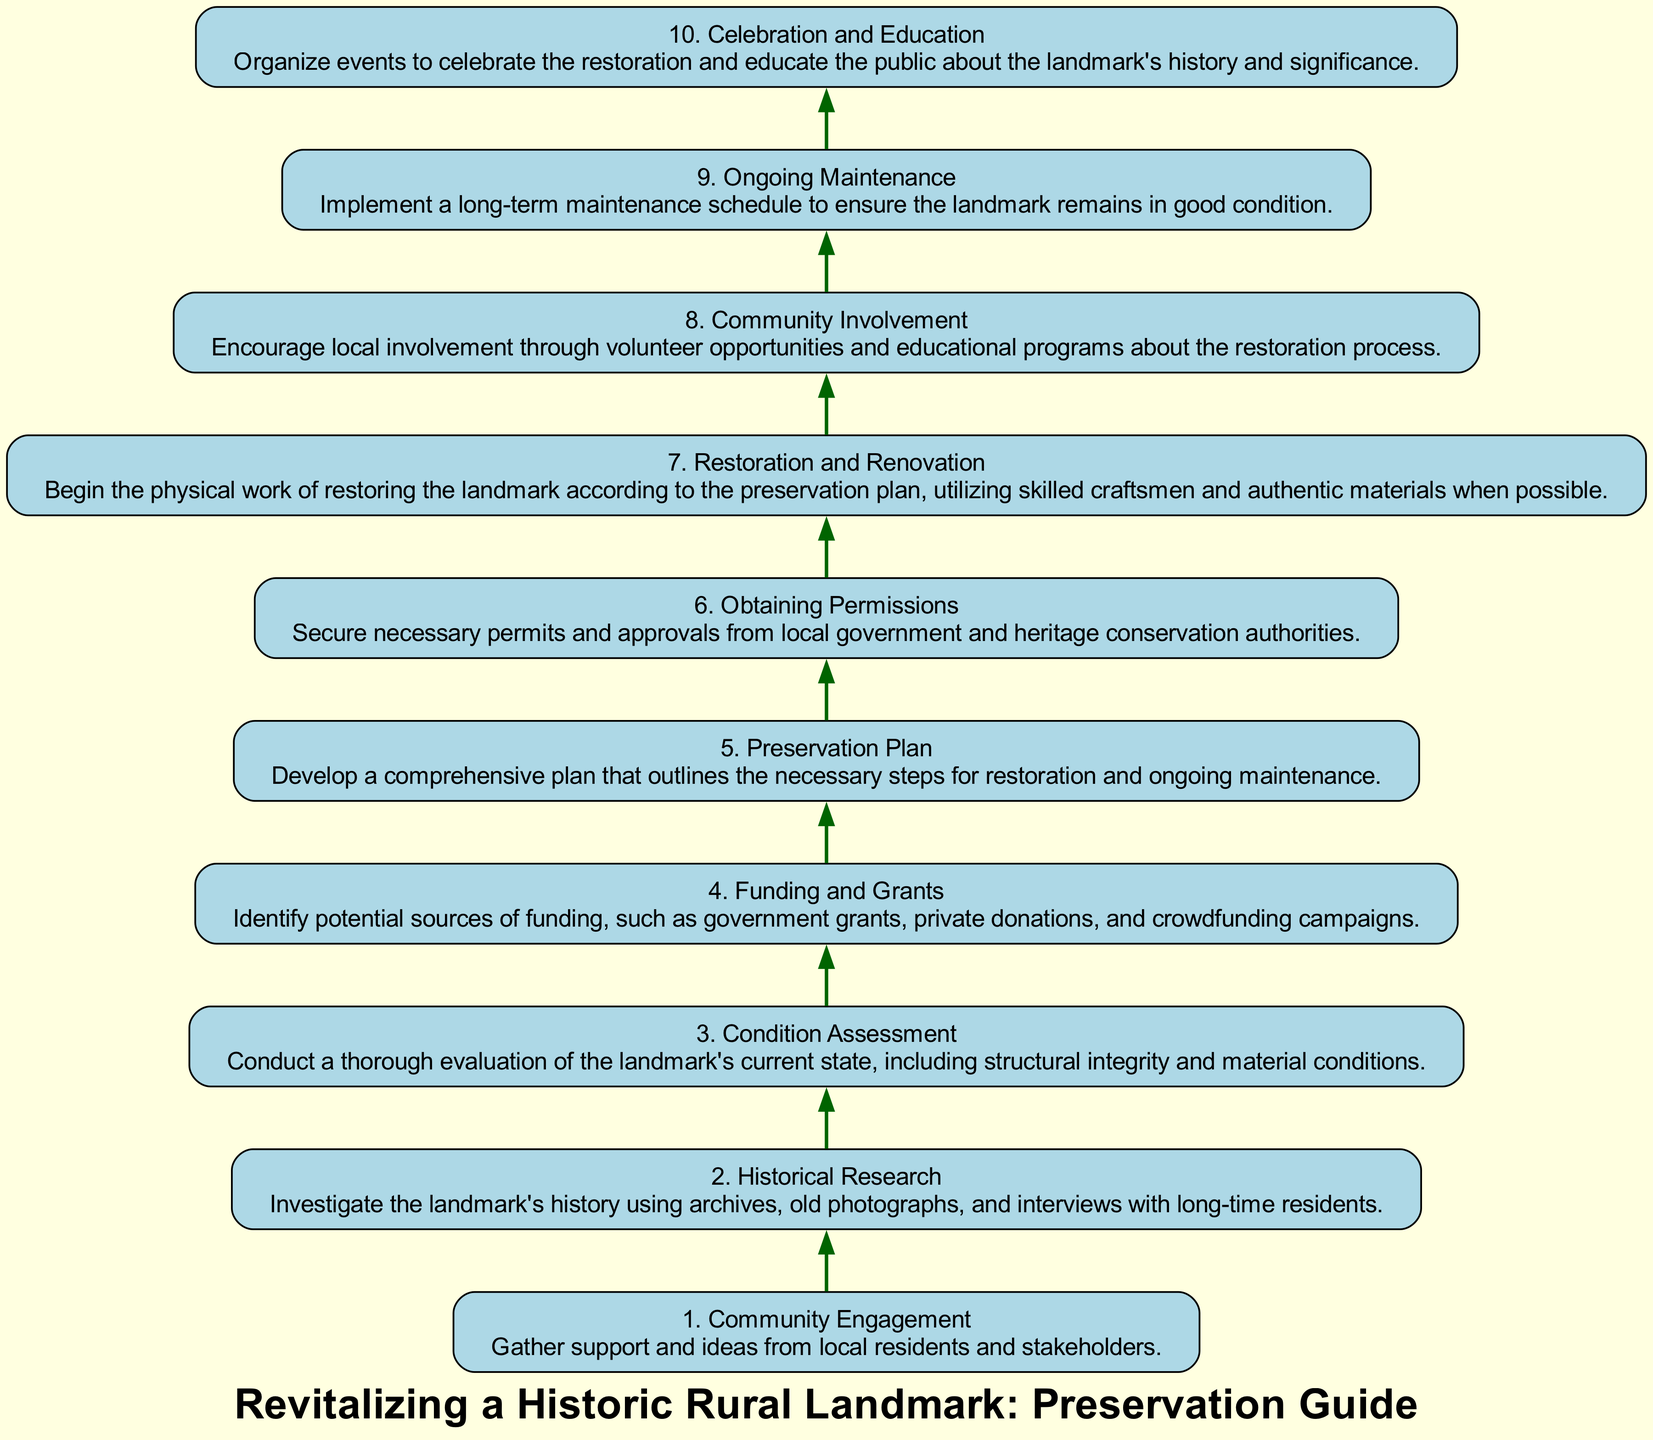What is the first step in the diagram? The first step listed in the diagram is "Community Engagement," which is indicated as step 1.
Answer: Community Engagement How many steps are there in total? The diagram includes 10 distinct steps, numbered from 1 to 10.
Answer: 10 What is the last step in the flow chart? The last step, which is step 10, is titled "Celebration and Education."
Answer: Celebration and Education What follows the "Condition Assessment"? "Funding and Grants" is the step that directly follows "Condition Assessment," indicating a sequence in the process.
Answer: Funding and Grants Which step involves restoration work? The step that involves actual restoration work is "Restoration and Renovation," marked as step 7 in the diagram.
Answer: Restoration and Renovation What step requires securing permits? The step that involves securing permits is "Obtaining Permissions," which is step 6 in the flow chart.
Answer: Obtaining Permissions What is the relationship between "Community Engagement" and "Ongoing Maintenance"? "Community Engagement" is the first step, and "Ongoing Maintenance" is the last step, indicating that community involvement is essential throughout the preservation process leading to ongoing care.
Answer: Community Engagement to Ongoing Maintenance What theme is central to both "Community Involvement" and "Celebration and Education"? Both steps emphasize local community engagement and education regarding the historic landmark, highlighting the importance of involving residents in the process and creating awareness about its significance.
Answer: Community involvement and education Which step emphasizes historical context? "Historical Research" is the step that emphasizes understanding the landmark's historical context, positioned as step 2 in the flow chart.
Answer: Historical Research 